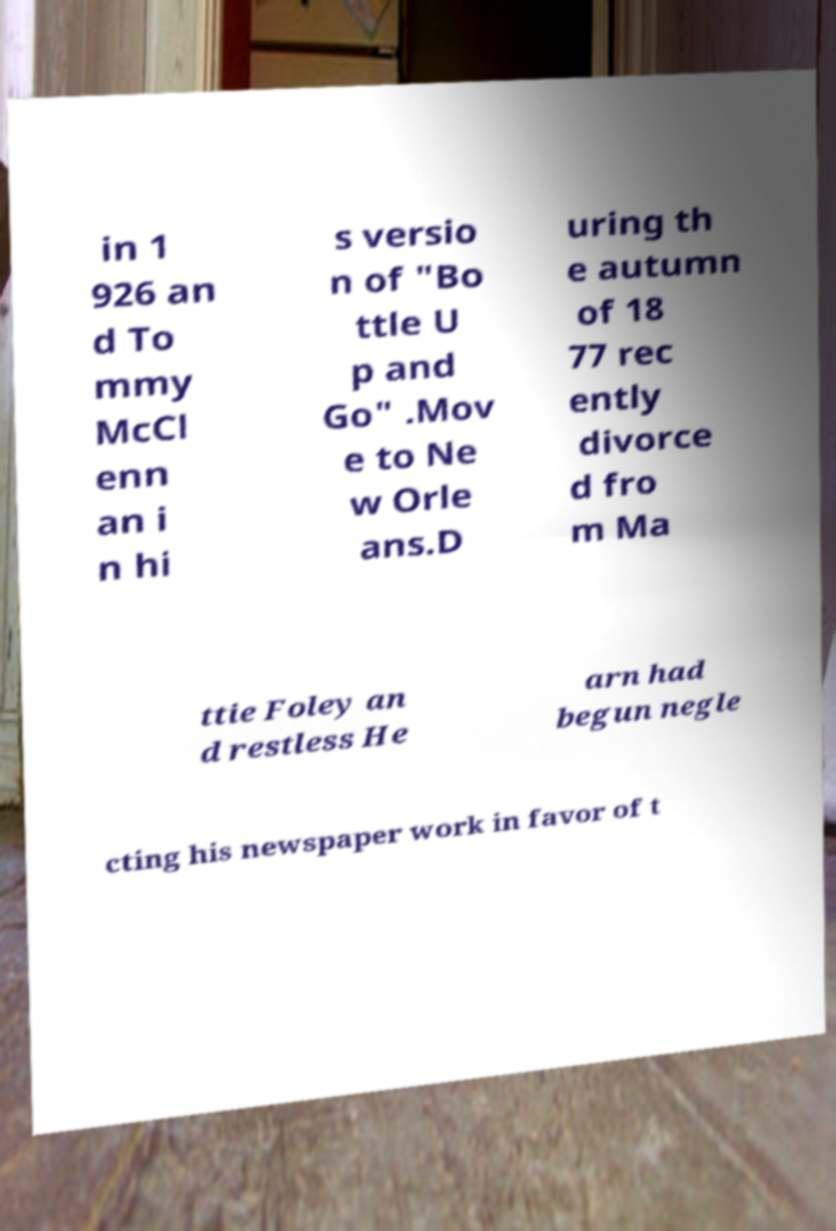Can you read and provide the text displayed in the image?This photo seems to have some interesting text. Can you extract and type it out for me? in 1 926 an d To mmy McCl enn an i n hi s versio n of "Bo ttle U p and Go" .Mov e to Ne w Orle ans.D uring th e autumn of 18 77 rec ently divorce d fro m Ma ttie Foley an d restless He arn had begun negle cting his newspaper work in favor of t 